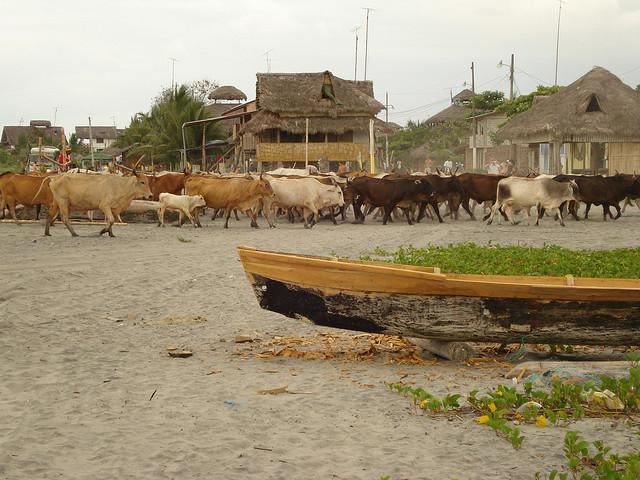What roofing method was used on these houses?

Choices:
A) wicked
B) raftered
C) gabled
D) thatching thatching 